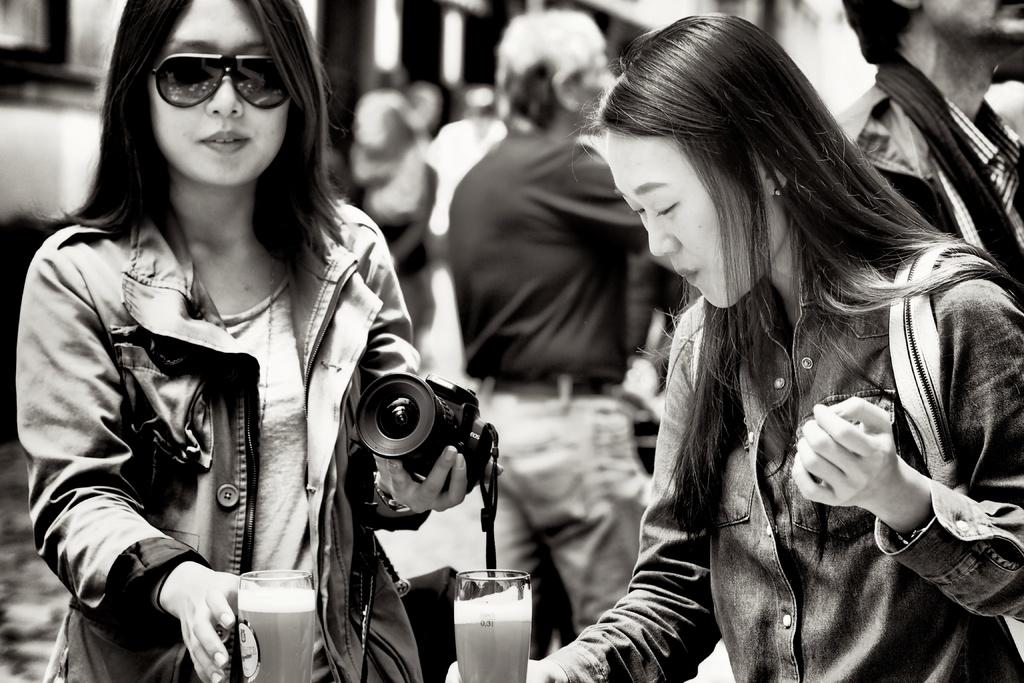How many people are in the image? There are two women in the image. What are the women about to do? The women are about to hold a glass. What object is one of the women holding? One of the women is holding a camera in her hand. What type of birds can be seen flying in the image? There are no birds visible in the image. What color is the crayon that the women are using in the image? There is no crayon present in the image. 